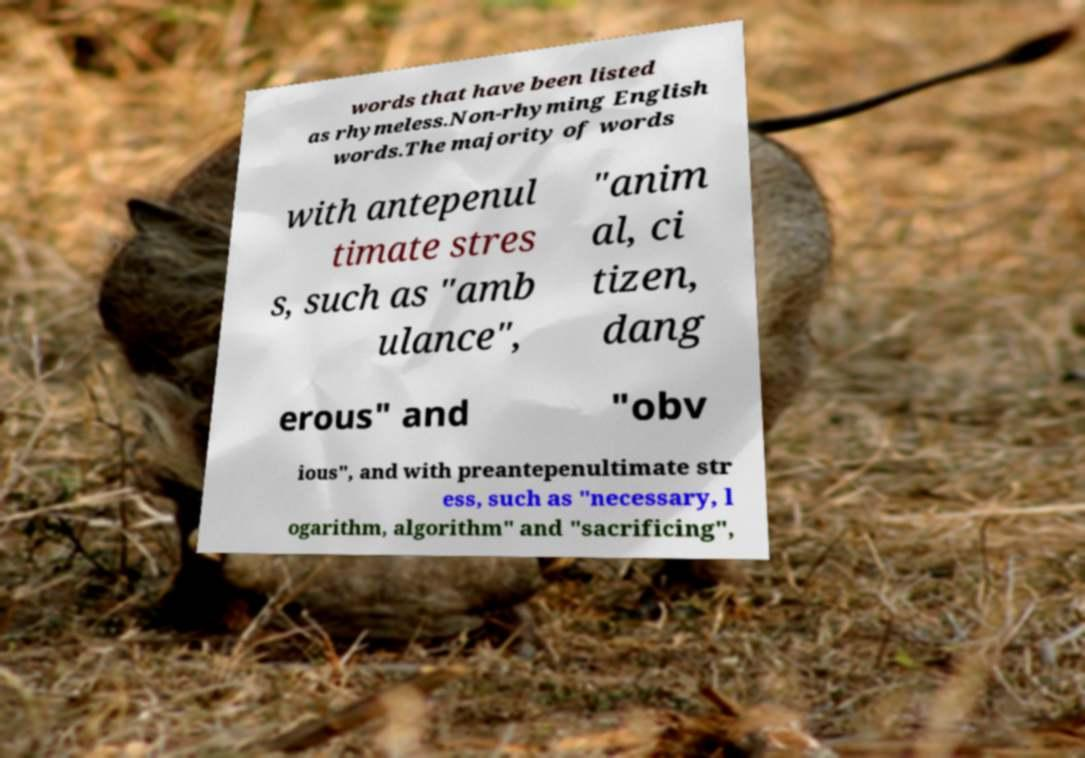Please read and relay the text visible in this image. What does it say? words that have been listed as rhymeless.Non-rhyming English words.The majority of words with antepenul timate stres s, such as "amb ulance", "anim al, ci tizen, dang erous" and "obv ious", and with preantepenultimate str ess, such as "necessary, l ogarithm, algorithm" and "sacrificing", 